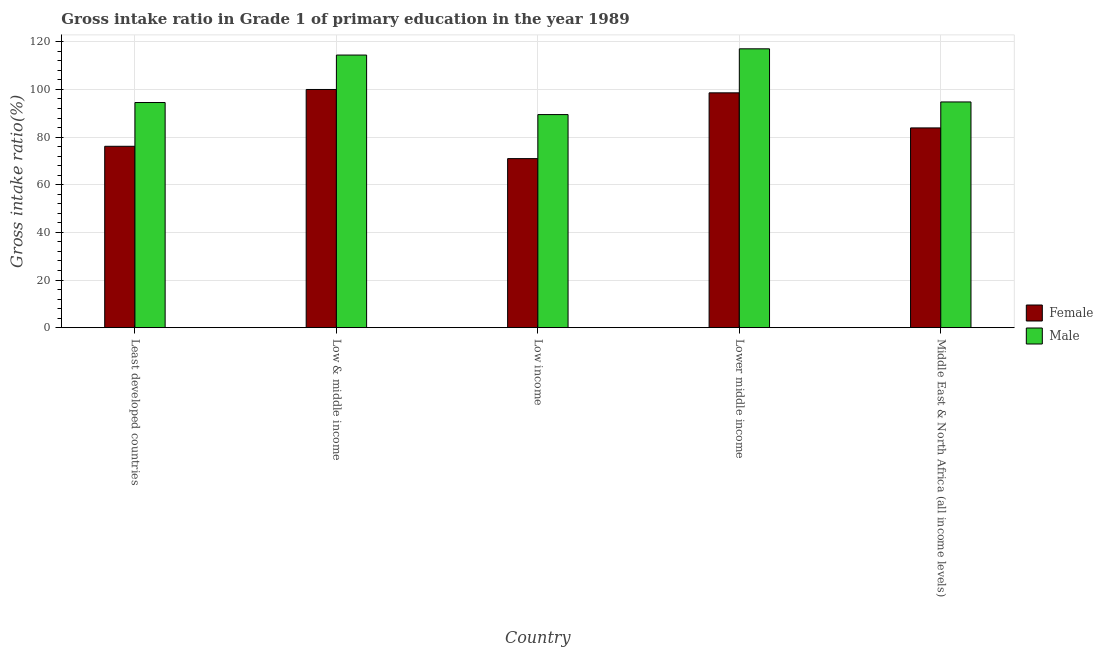How many groups of bars are there?
Provide a short and direct response. 5. Are the number of bars per tick equal to the number of legend labels?
Ensure brevity in your answer.  Yes. How many bars are there on the 2nd tick from the left?
Ensure brevity in your answer.  2. What is the label of the 2nd group of bars from the left?
Keep it short and to the point. Low & middle income. In how many cases, is the number of bars for a given country not equal to the number of legend labels?
Keep it short and to the point. 0. What is the gross intake ratio(male) in Lower middle income?
Your answer should be very brief. 117.06. Across all countries, what is the maximum gross intake ratio(male)?
Your answer should be very brief. 117.06. Across all countries, what is the minimum gross intake ratio(male)?
Your answer should be very brief. 89.45. In which country was the gross intake ratio(male) minimum?
Offer a very short reply. Low income. What is the total gross intake ratio(male) in the graph?
Keep it short and to the point. 510.23. What is the difference between the gross intake ratio(male) in Least developed countries and that in Middle East & North Africa (all income levels)?
Provide a succinct answer. -0.24. What is the difference between the gross intake ratio(male) in Lower middle income and the gross intake ratio(female) in Low & middle income?
Your response must be concise. 17.07. What is the average gross intake ratio(male) per country?
Your answer should be very brief. 102.05. What is the difference between the gross intake ratio(male) and gross intake ratio(female) in Least developed countries?
Your response must be concise. 18.37. What is the ratio of the gross intake ratio(male) in Least developed countries to that in Middle East & North Africa (all income levels)?
Provide a succinct answer. 1. Is the gross intake ratio(female) in Least developed countries less than that in Middle East & North Africa (all income levels)?
Make the answer very short. Yes. What is the difference between the highest and the second highest gross intake ratio(male)?
Provide a short and direct response. 2.62. What is the difference between the highest and the lowest gross intake ratio(female)?
Provide a short and direct response. 29.03. In how many countries, is the gross intake ratio(male) greater than the average gross intake ratio(male) taken over all countries?
Offer a terse response. 2. Is the sum of the gross intake ratio(male) in Lower middle income and Middle East & North Africa (all income levels) greater than the maximum gross intake ratio(female) across all countries?
Your answer should be very brief. Yes. What does the 1st bar from the right in Least developed countries represents?
Make the answer very short. Male. How many bars are there?
Provide a short and direct response. 10. How many countries are there in the graph?
Keep it short and to the point. 5. What is the difference between two consecutive major ticks on the Y-axis?
Give a very brief answer. 20. Are the values on the major ticks of Y-axis written in scientific E-notation?
Provide a succinct answer. No. Does the graph contain any zero values?
Ensure brevity in your answer.  No. Does the graph contain grids?
Provide a succinct answer. Yes. How many legend labels are there?
Provide a succinct answer. 2. What is the title of the graph?
Offer a very short reply. Gross intake ratio in Grade 1 of primary education in the year 1989. Does "Private creditors" appear as one of the legend labels in the graph?
Ensure brevity in your answer.  No. What is the label or title of the Y-axis?
Offer a terse response. Gross intake ratio(%). What is the Gross intake ratio(%) of Female in Least developed countries?
Your answer should be compact. 76.14. What is the Gross intake ratio(%) of Male in Least developed countries?
Provide a succinct answer. 94.52. What is the Gross intake ratio(%) in Female in Low & middle income?
Your answer should be very brief. 99.99. What is the Gross intake ratio(%) in Male in Low & middle income?
Keep it short and to the point. 114.44. What is the Gross intake ratio(%) in Female in Low income?
Offer a terse response. 70.97. What is the Gross intake ratio(%) in Male in Low income?
Ensure brevity in your answer.  89.45. What is the Gross intake ratio(%) in Female in Lower middle income?
Your answer should be compact. 98.58. What is the Gross intake ratio(%) of Male in Lower middle income?
Provide a short and direct response. 117.06. What is the Gross intake ratio(%) of Female in Middle East & North Africa (all income levels)?
Give a very brief answer. 83.86. What is the Gross intake ratio(%) in Male in Middle East & North Africa (all income levels)?
Your answer should be compact. 94.76. Across all countries, what is the maximum Gross intake ratio(%) in Female?
Offer a terse response. 99.99. Across all countries, what is the maximum Gross intake ratio(%) of Male?
Your response must be concise. 117.06. Across all countries, what is the minimum Gross intake ratio(%) of Female?
Ensure brevity in your answer.  70.97. Across all countries, what is the minimum Gross intake ratio(%) in Male?
Provide a short and direct response. 89.45. What is the total Gross intake ratio(%) in Female in the graph?
Your answer should be compact. 429.54. What is the total Gross intake ratio(%) in Male in the graph?
Provide a succinct answer. 510.23. What is the difference between the Gross intake ratio(%) in Female in Least developed countries and that in Low & middle income?
Your response must be concise. -23.85. What is the difference between the Gross intake ratio(%) in Male in Least developed countries and that in Low & middle income?
Provide a short and direct response. -19.93. What is the difference between the Gross intake ratio(%) of Female in Least developed countries and that in Low income?
Your answer should be very brief. 5.18. What is the difference between the Gross intake ratio(%) of Male in Least developed countries and that in Low income?
Keep it short and to the point. 5.06. What is the difference between the Gross intake ratio(%) of Female in Least developed countries and that in Lower middle income?
Provide a short and direct response. -22.44. What is the difference between the Gross intake ratio(%) in Male in Least developed countries and that in Lower middle income?
Ensure brevity in your answer.  -22.55. What is the difference between the Gross intake ratio(%) in Female in Least developed countries and that in Middle East & North Africa (all income levels)?
Your answer should be compact. -7.72. What is the difference between the Gross intake ratio(%) of Male in Least developed countries and that in Middle East & North Africa (all income levels)?
Provide a succinct answer. -0.24. What is the difference between the Gross intake ratio(%) of Female in Low & middle income and that in Low income?
Keep it short and to the point. 29.03. What is the difference between the Gross intake ratio(%) of Male in Low & middle income and that in Low income?
Keep it short and to the point. 24.99. What is the difference between the Gross intake ratio(%) in Female in Low & middle income and that in Lower middle income?
Your answer should be very brief. 1.41. What is the difference between the Gross intake ratio(%) of Male in Low & middle income and that in Lower middle income?
Provide a succinct answer. -2.62. What is the difference between the Gross intake ratio(%) in Female in Low & middle income and that in Middle East & North Africa (all income levels)?
Provide a succinct answer. 16.13. What is the difference between the Gross intake ratio(%) of Male in Low & middle income and that in Middle East & North Africa (all income levels)?
Keep it short and to the point. 19.68. What is the difference between the Gross intake ratio(%) of Female in Low income and that in Lower middle income?
Offer a very short reply. -27.61. What is the difference between the Gross intake ratio(%) in Male in Low income and that in Lower middle income?
Make the answer very short. -27.61. What is the difference between the Gross intake ratio(%) of Female in Low income and that in Middle East & North Africa (all income levels)?
Keep it short and to the point. -12.89. What is the difference between the Gross intake ratio(%) in Male in Low income and that in Middle East & North Africa (all income levels)?
Provide a short and direct response. -5.31. What is the difference between the Gross intake ratio(%) of Female in Lower middle income and that in Middle East & North Africa (all income levels)?
Provide a succinct answer. 14.72. What is the difference between the Gross intake ratio(%) in Male in Lower middle income and that in Middle East & North Africa (all income levels)?
Offer a terse response. 22.3. What is the difference between the Gross intake ratio(%) in Female in Least developed countries and the Gross intake ratio(%) in Male in Low & middle income?
Your answer should be compact. -38.3. What is the difference between the Gross intake ratio(%) in Female in Least developed countries and the Gross intake ratio(%) in Male in Low income?
Keep it short and to the point. -13.31. What is the difference between the Gross intake ratio(%) in Female in Least developed countries and the Gross intake ratio(%) in Male in Lower middle income?
Ensure brevity in your answer.  -40.92. What is the difference between the Gross intake ratio(%) in Female in Least developed countries and the Gross intake ratio(%) in Male in Middle East & North Africa (all income levels)?
Keep it short and to the point. -18.62. What is the difference between the Gross intake ratio(%) in Female in Low & middle income and the Gross intake ratio(%) in Male in Low income?
Offer a very short reply. 10.54. What is the difference between the Gross intake ratio(%) in Female in Low & middle income and the Gross intake ratio(%) in Male in Lower middle income?
Keep it short and to the point. -17.07. What is the difference between the Gross intake ratio(%) of Female in Low & middle income and the Gross intake ratio(%) of Male in Middle East & North Africa (all income levels)?
Your response must be concise. 5.23. What is the difference between the Gross intake ratio(%) of Female in Low income and the Gross intake ratio(%) of Male in Lower middle income?
Offer a terse response. -46.1. What is the difference between the Gross intake ratio(%) in Female in Low income and the Gross intake ratio(%) in Male in Middle East & North Africa (all income levels)?
Give a very brief answer. -23.79. What is the difference between the Gross intake ratio(%) in Female in Lower middle income and the Gross intake ratio(%) in Male in Middle East & North Africa (all income levels)?
Your answer should be compact. 3.82. What is the average Gross intake ratio(%) in Female per country?
Make the answer very short. 85.91. What is the average Gross intake ratio(%) of Male per country?
Your answer should be very brief. 102.05. What is the difference between the Gross intake ratio(%) in Female and Gross intake ratio(%) in Male in Least developed countries?
Offer a very short reply. -18.37. What is the difference between the Gross intake ratio(%) in Female and Gross intake ratio(%) in Male in Low & middle income?
Your response must be concise. -14.45. What is the difference between the Gross intake ratio(%) of Female and Gross intake ratio(%) of Male in Low income?
Your answer should be very brief. -18.48. What is the difference between the Gross intake ratio(%) in Female and Gross intake ratio(%) in Male in Lower middle income?
Keep it short and to the point. -18.48. What is the difference between the Gross intake ratio(%) of Female and Gross intake ratio(%) of Male in Middle East & North Africa (all income levels)?
Your answer should be compact. -10.9. What is the ratio of the Gross intake ratio(%) of Female in Least developed countries to that in Low & middle income?
Keep it short and to the point. 0.76. What is the ratio of the Gross intake ratio(%) of Male in Least developed countries to that in Low & middle income?
Provide a short and direct response. 0.83. What is the ratio of the Gross intake ratio(%) in Female in Least developed countries to that in Low income?
Offer a very short reply. 1.07. What is the ratio of the Gross intake ratio(%) of Male in Least developed countries to that in Low income?
Make the answer very short. 1.06. What is the ratio of the Gross intake ratio(%) in Female in Least developed countries to that in Lower middle income?
Your answer should be compact. 0.77. What is the ratio of the Gross intake ratio(%) of Male in Least developed countries to that in Lower middle income?
Make the answer very short. 0.81. What is the ratio of the Gross intake ratio(%) in Female in Least developed countries to that in Middle East & North Africa (all income levels)?
Offer a very short reply. 0.91. What is the ratio of the Gross intake ratio(%) of Male in Least developed countries to that in Middle East & North Africa (all income levels)?
Provide a succinct answer. 1. What is the ratio of the Gross intake ratio(%) of Female in Low & middle income to that in Low income?
Offer a very short reply. 1.41. What is the ratio of the Gross intake ratio(%) of Male in Low & middle income to that in Low income?
Provide a succinct answer. 1.28. What is the ratio of the Gross intake ratio(%) in Female in Low & middle income to that in Lower middle income?
Provide a succinct answer. 1.01. What is the ratio of the Gross intake ratio(%) in Male in Low & middle income to that in Lower middle income?
Offer a very short reply. 0.98. What is the ratio of the Gross intake ratio(%) of Female in Low & middle income to that in Middle East & North Africa (all income levels)?
Provide a short and direct response. 1.19. What is the ratio of the Gross intake ratio(%) in Male in Low & middle income to that in Middle East & North Africa (all income levels)?
Provide a succinct answer. 1.21. What is the ratio of the Gross intake ratio(%) in Female in Low income to that in Lower middle income?
Keep it short and to the point. 0.72. What is the ratio of the Gross intake ratio(%) of Male in Low income to that in Lower middle income?
Your response must be concise. 0.76. What is the ratio of the Gross intake ratio(%) in Female in Low income to that in Middle East & North Africa (all income levels)?
Make the answer very short. 0.85. What is the ratio of the Gross intake ratio(%) in Male in Low income to that in Middle East & North Africa (all income levels)?
Your response must be concise. 0.94. What is the ratio of the Gross intake ratio(%) of Female in Lower middle income to that in Middle East & North Africa (all income levels)?
Offer a very short reply. 1.18. What is the ratio of the Gross intake ratio(%) in Male in Lower middle income to that in Middle East & North Africa (all income levels)?
Your response must be concise. 1.24. What is the difference between the highest and the second highest Gross intake ratio(%) in Female?
Offer a terse response. 1.41. What is the difference between the highest and the second highest Gross intake ratio(%) of Male?
Your response must be concise. 2.62. What is the difference between the highest and the lowest Gross intake ratio(%) in Female?
Your response must be concise. 29.03. What is the difference between the highest and the lowest Gross intake ratio(%) of Male?
Ensure brevity in your answer.  27.61. 